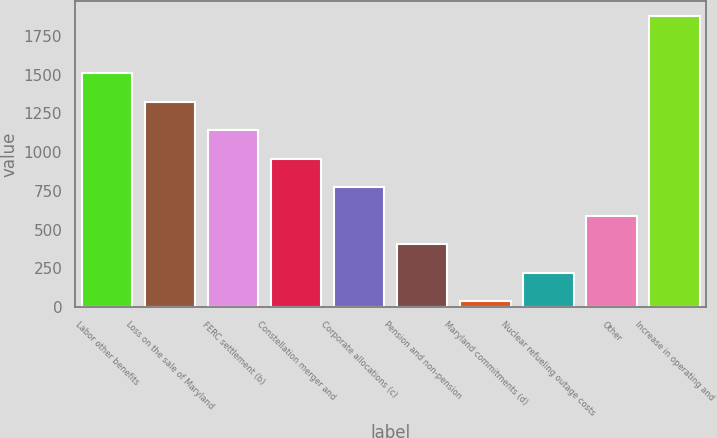<chart> <loc_0><loc_0><loc_500><loc_500><bar_chart><fcel>Labor other benefits<fcel>Loss on the sale of Maryland<fcel>FERC settlement (b)<fcel>Constellation merger and<fcel>Corporate allocations (c)<fcel>Pension and non-pension<fcel>Maryland commitments (d)<fcel>Nuclear refueling outage costs<fcel>Other<fcel>Increase in operating and<nl><fcel>1511<fcel>1326.5<fcel>1142<fcel>957.5<fcel>773<fcel>404<fcel>35<fcel>219.5<fcel>588.5<fcel>1880<nl></chart> 